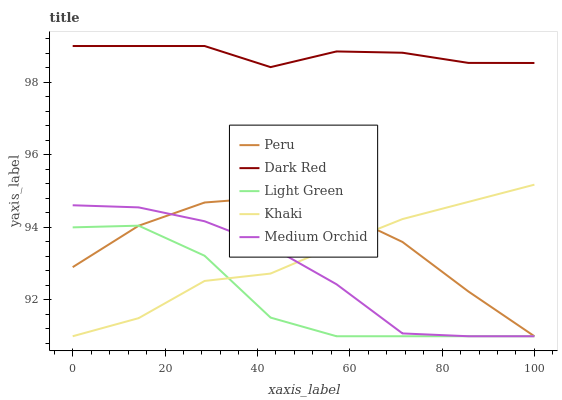Does Light Green have the minimum area under the curve?
Answer yes or no. Yes. Does Dark Red have the maximum area under the curve?
Answer yes or no. Yes. Does Medium Orchid have the minimum area under the curve?
Answer yes or no. No. Does Medium Orchid have the maximum area under the curve?
Answer yes or no. No. Is Khaki the smoothest?
Answer yes or no. Yes. Is Light Green the roughest?
Answer yes or no. Yes. Is Medium Orchid the smoothest?
Answer yes or no. No. Is Medium Orchid the roughest?
Answer yes or no. No. Does Medium Orchid have the lowest value?
Answer yes or no. Yes. Does Dark Red have the highest value?
Answer yes or no. Yes. Does Medium Orchid have the highest value?
Answer yes or no. No. Is Khaki less than Dark Red?
Answer yes or no. Yes. Is Dark Red greater than Light Green?
Answer yes or no. Yes. Does Khaki intersect Peru?
Answer yes or no. Yes. Is Khaki less than Peru?
Answer yes or no. No. Is Khaki greater than Peru?
Answer yes or no. No. Does Khaki intersect Dark Red?
Answer yes or no. No. 